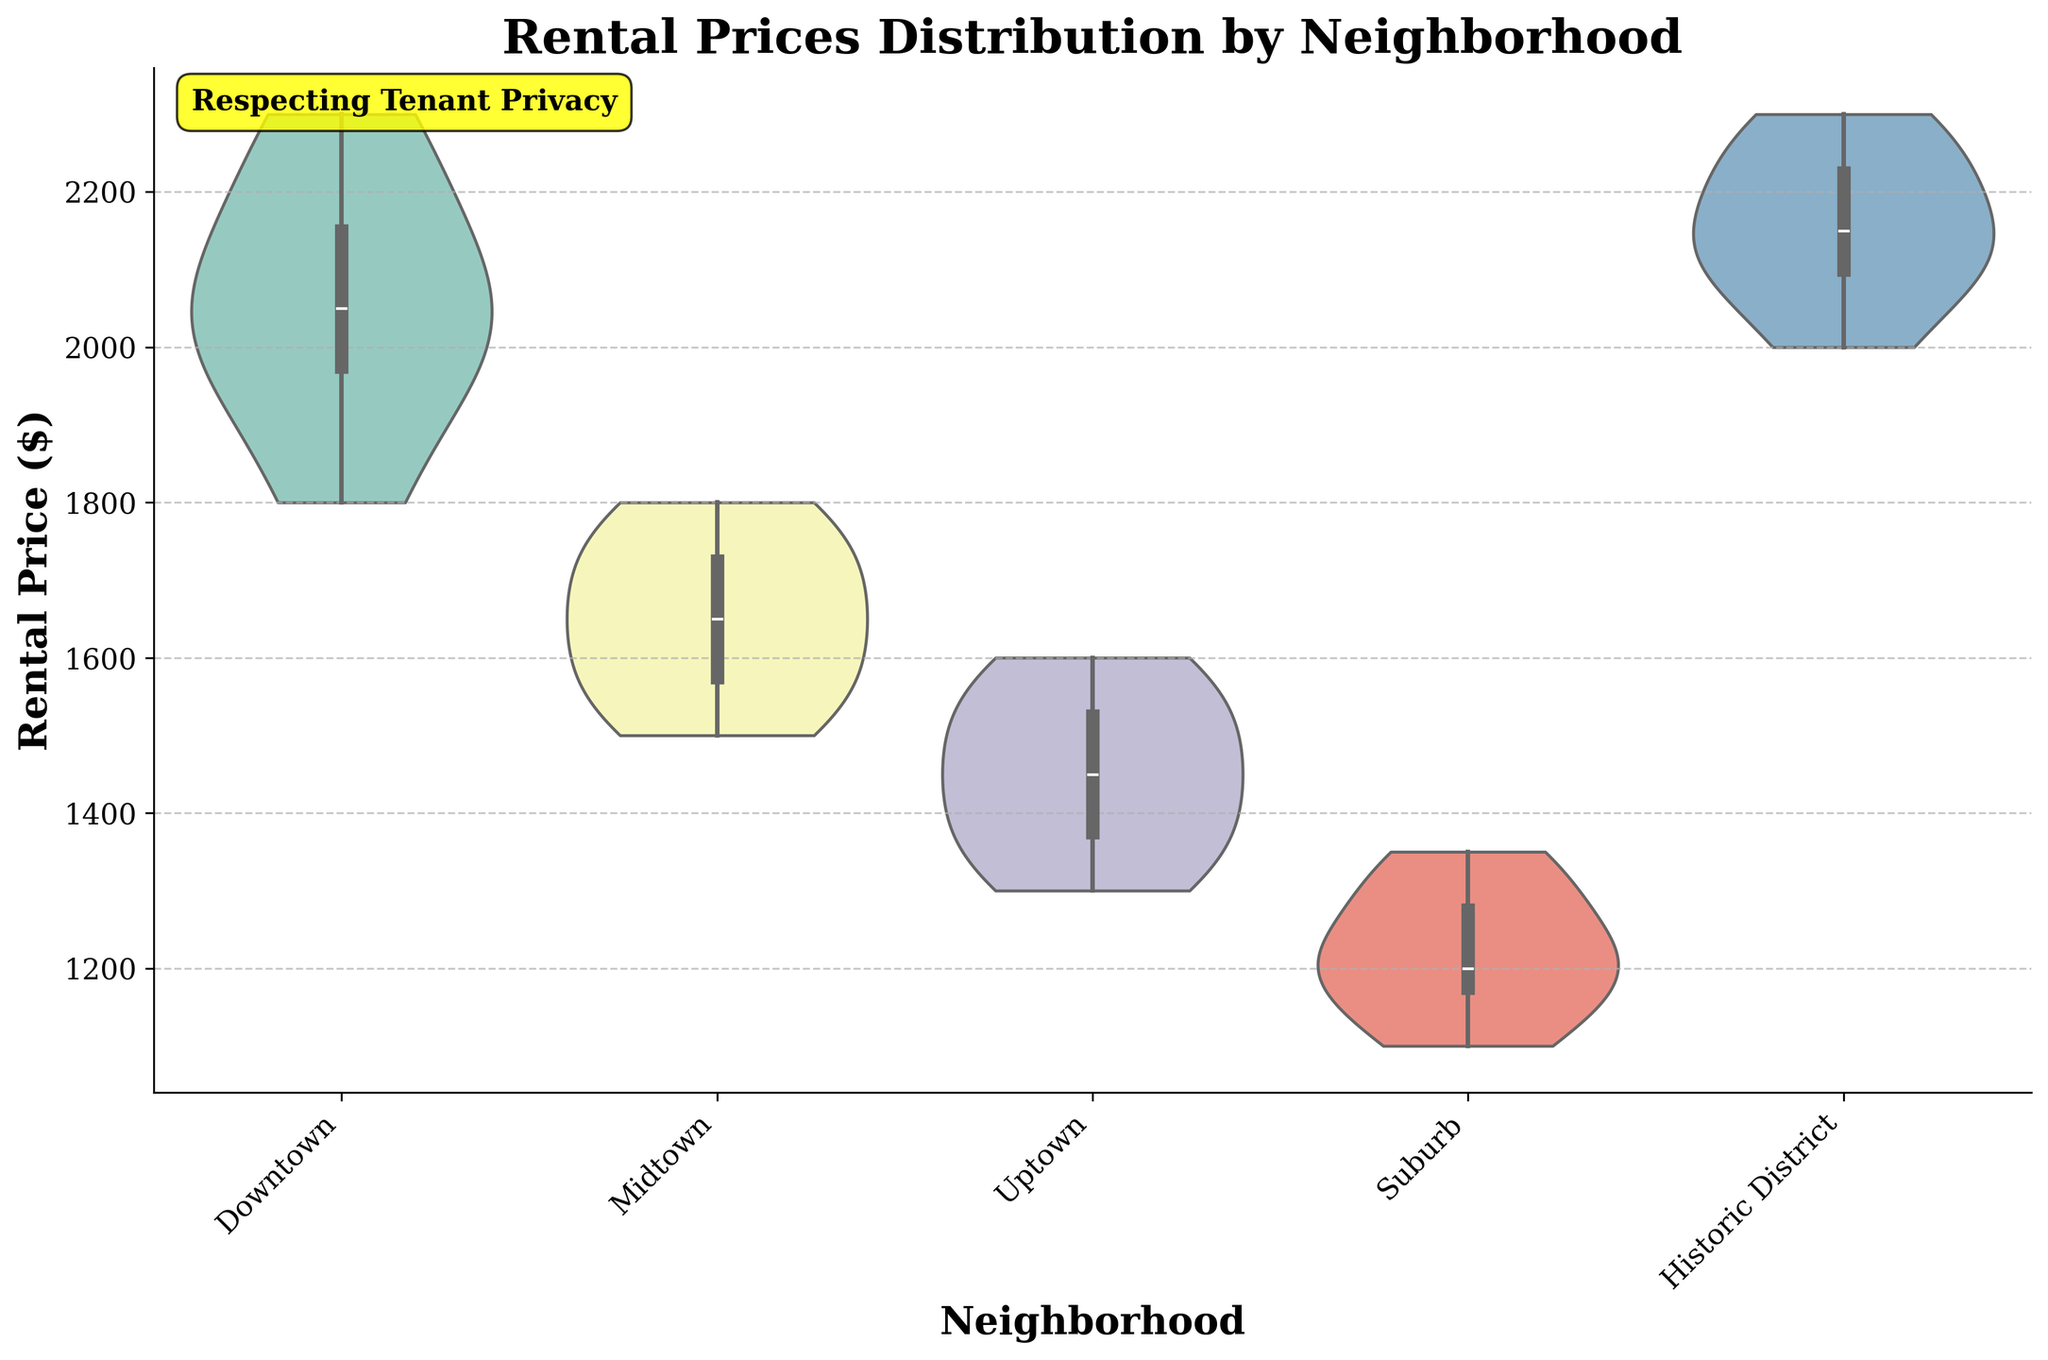What is the title of the figure? The title of the figure is generally located at the top of the chart. By looking at this location, we can observe that the title for this figure is clearly stated as 'Rental Prices Distribution by Neighborhood'.
Answer: Rental Prices Distribution by Neighborhood Which neighborhood has the highest median rental price? The median rental price in a violin plot is typically visualized as a white dot or line within the inner box. By observing these medians, the highest one is found in the Downtown neighborhood.
Answer: Downtown How do the rental prices in the Suburb neighborhood compare to those in the Uptown neighborhood? To compare the rental prices, we look at the spread and center of the distributions. The Suburb neighborhood shows a lower spread and lower median compared to Uptown, which has a slightly higher median and wider spread.
Answer: Suburb has lower rental prices than Uptown What is the range of rental prices in the Historic District neighborhood? To find the range, we observe the top and bottom of the violin plot for the Historic District. The maximum rental price appears to be around $2300 and the minimum around $2000, thus the range is $300.
Answer: $300 Which neighborhood has the most spread out rental prices? We determine the spread by looking at the width of the violin plots. The Downtown neighborhood shows the widest spread of rental prices, indicating the most variability.
Answer: Downtown Which neighborhood has the narrowest distribution of rental prices? The narrowest distribution is identified by finding the neighborhood with the smallest spread in the violin plot. The Suburb neighborhood shows the narrowest distribution compared to the others.
Answer: Suburb What are the quartiles (25th and 75th percentiles) of rental prices in Midtown? Quartiles in a violin plot are generally depicted inside the box in the middle. By observing these for the Midtown neighborhood, the 25th percentile is at about $1550 and the 75th percentile at about $1700.
Answer: 25th: $1550, 75th: $1700 Which neighborhoods have overlapping rental prices distributions? Overlapping distributions can be seen where the violin plots overlap significantly in height and spread. The Midtown and Uptown neighborhoods have overlapping rental price distributions.
Answer: Midtown and Uptown Is the median rental price in the Historic District higher or lower than in Downtown? By comparing the median lines in the Historic District and Downtown, we can see that the median rental price in the Historic District is slightly higher than in Downtown.
Answer: Higher What does the text 'Respecting Tenant Privacy' signify in the context of this chart? The annotation 'Respecting Tenant Privacy' is a note emphasizing a commitment to privacy. It’s placed to align with the property owner's value of protecting tenant information while presenting the rental price data.
Answer: Emphasizing privacy 